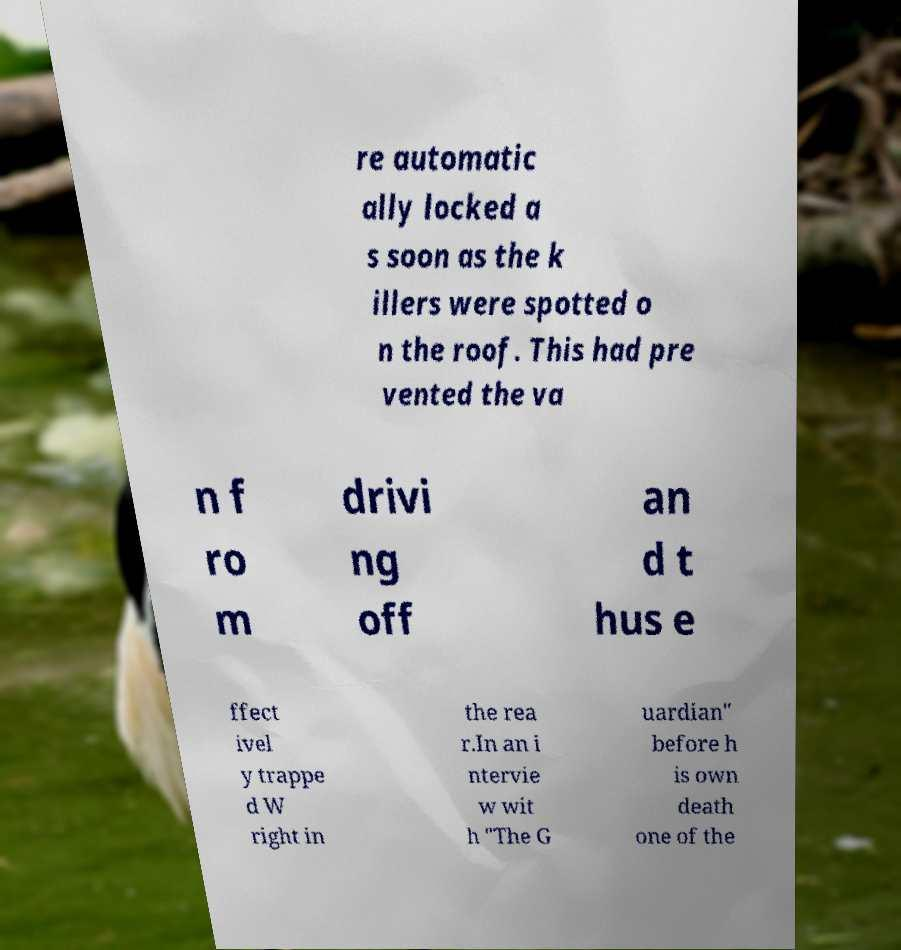Can you read and provide the text displayed in the image?This photo seems to have some interesting text. Can you extract and type it out for me? re automatic ally locked a s soon as the k illers were spotted o n the roof. This had pre vented the va n f ro m drivi ng off an d t hus e ffect ivel y trappe d W right in the rea r.In an i ntervie w wit h "The G uardian" before h is own death one of the 